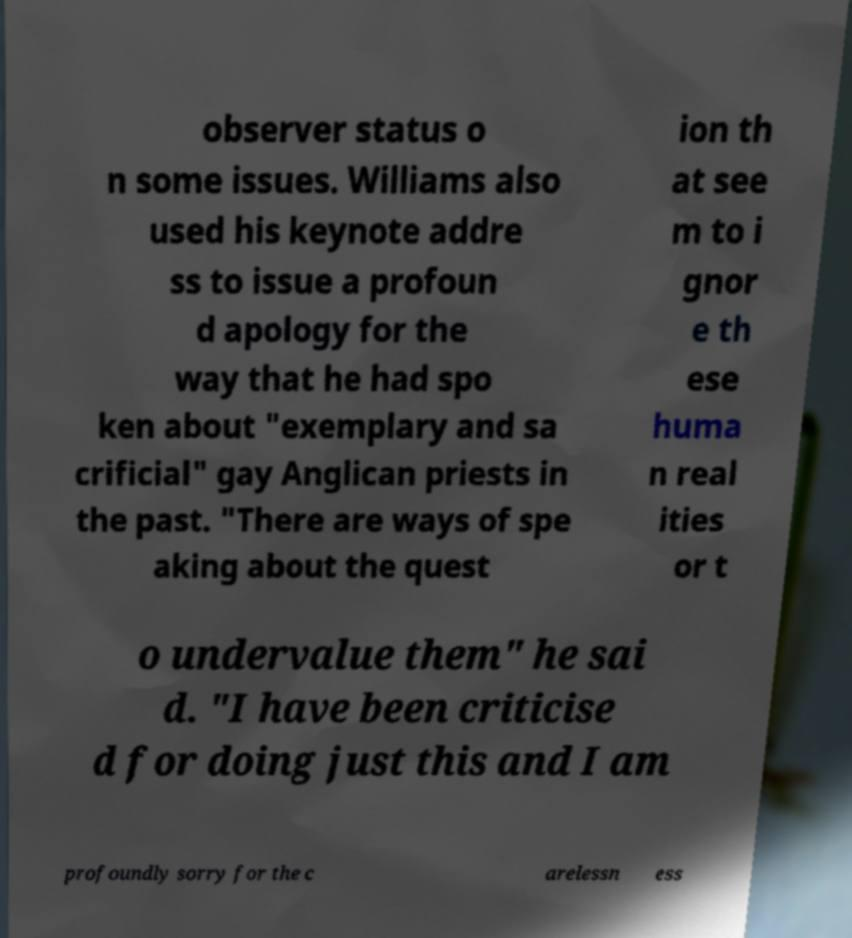What messages or text are displayed in this image? I need them in a readable, typed format. observer status o n some issues. Williams also used his keynote addre ss to issue a profoun d apology for the way that he had spo ken about "exemplary and sa crificial" gay Anglican priests in the past. "There are ways of spe aking about the quest ion th at see m to i gnor e th ese huma n real ities or t o undervalue them" he sai d. "I have been criticise d for doing just this and I am profoundly sorry for the c arelessn ess 